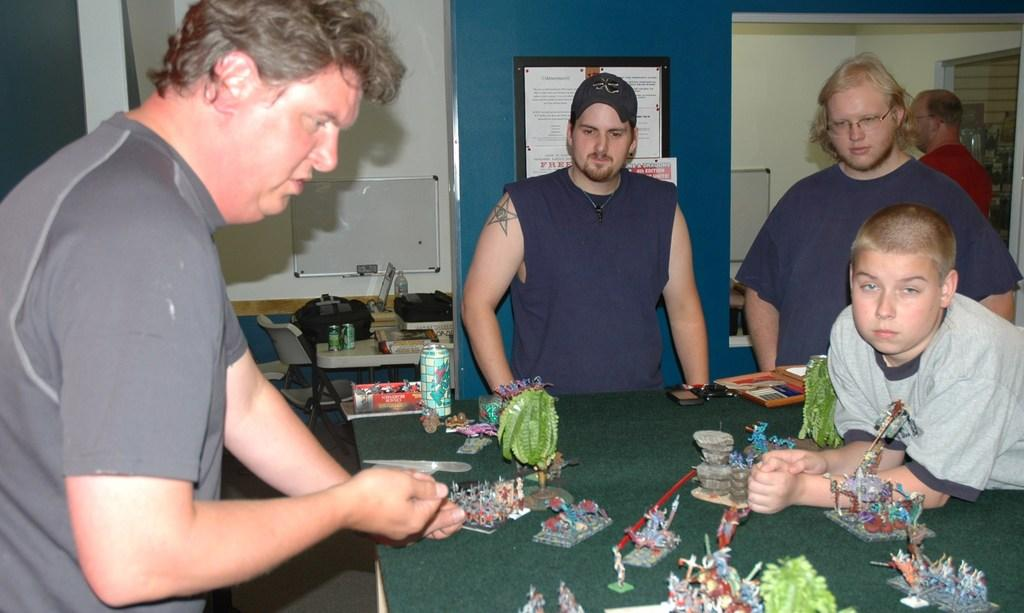What can be seen in the background of the image? In the background of the image, there is a wall, a whiteboard, and frames. What objects are present on the table in the image? On the table, there are miniatures, tins, and bags. Are there any people in the image? Yes, there are people standing in the image. Can you tell me how many bees are collecting honey from the farm in the image? There is no farm or bees collecting honey present in the image. What type of flight is depicted on the wall in the image? There is no flight depicted on the wall in the image; only a wall, a whiteboard, and frames are present. 